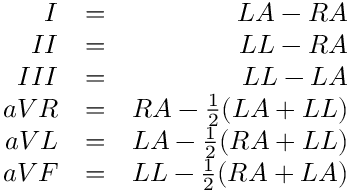<formula> <loc_0><loc_0><loc_500><loc_500>\begin{array} { r l r } { I } & { = } & { L A - R A } \\ { I I } & { = } & { L L - R A } \\ { I I I } & { = } & { L L - L A } \\ { a V R } & { = } & { R A - \frac { 1 } { 2 } ( L A + L L ) } \\ { a V L } & { = } & { L A - \frac { 1 } { 2 } ( R A + L L ) } \\ { a V F } & { = } & { L L - \frac { 1 } { 2 } ( R A + L A ) } \end{array}</formula> 